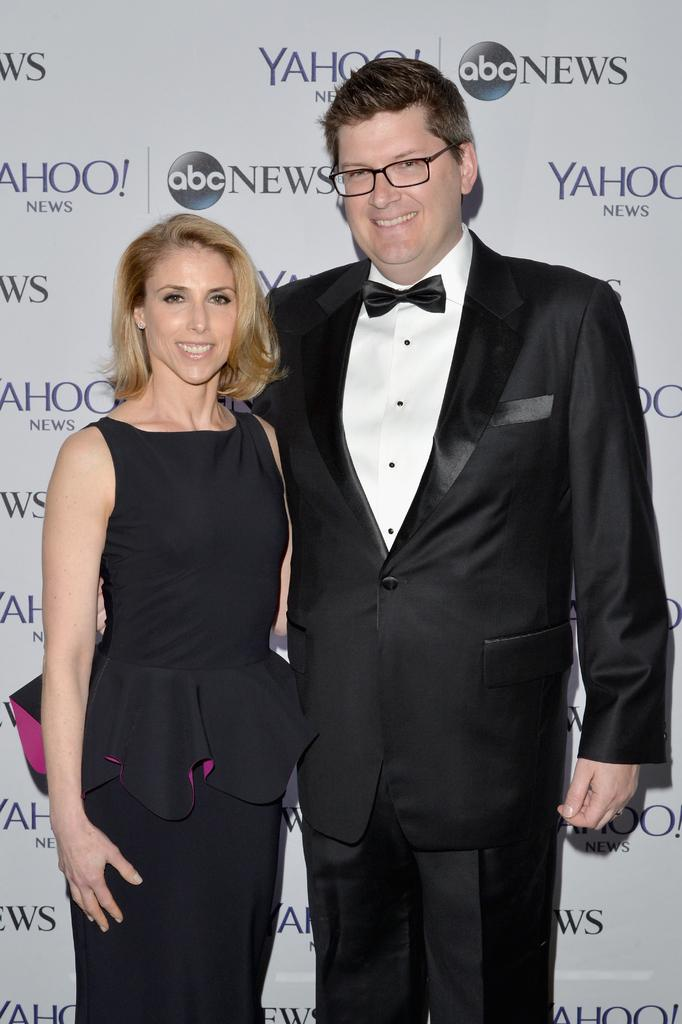<image>
Offer a succinct explanation of the picture presented. A famous couple standing on a yahoo and abc news background. 